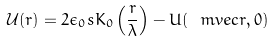<formula> <loc_0><loc_0><loc_500><loc_500>\mathcal { U } ( r ) = 2 \epsilon _ { 0 } s K _ { 0 } \left ( \frac { r } { \lambda } \right ) - U ( \ m v e c { r } , 0 )</formula> 